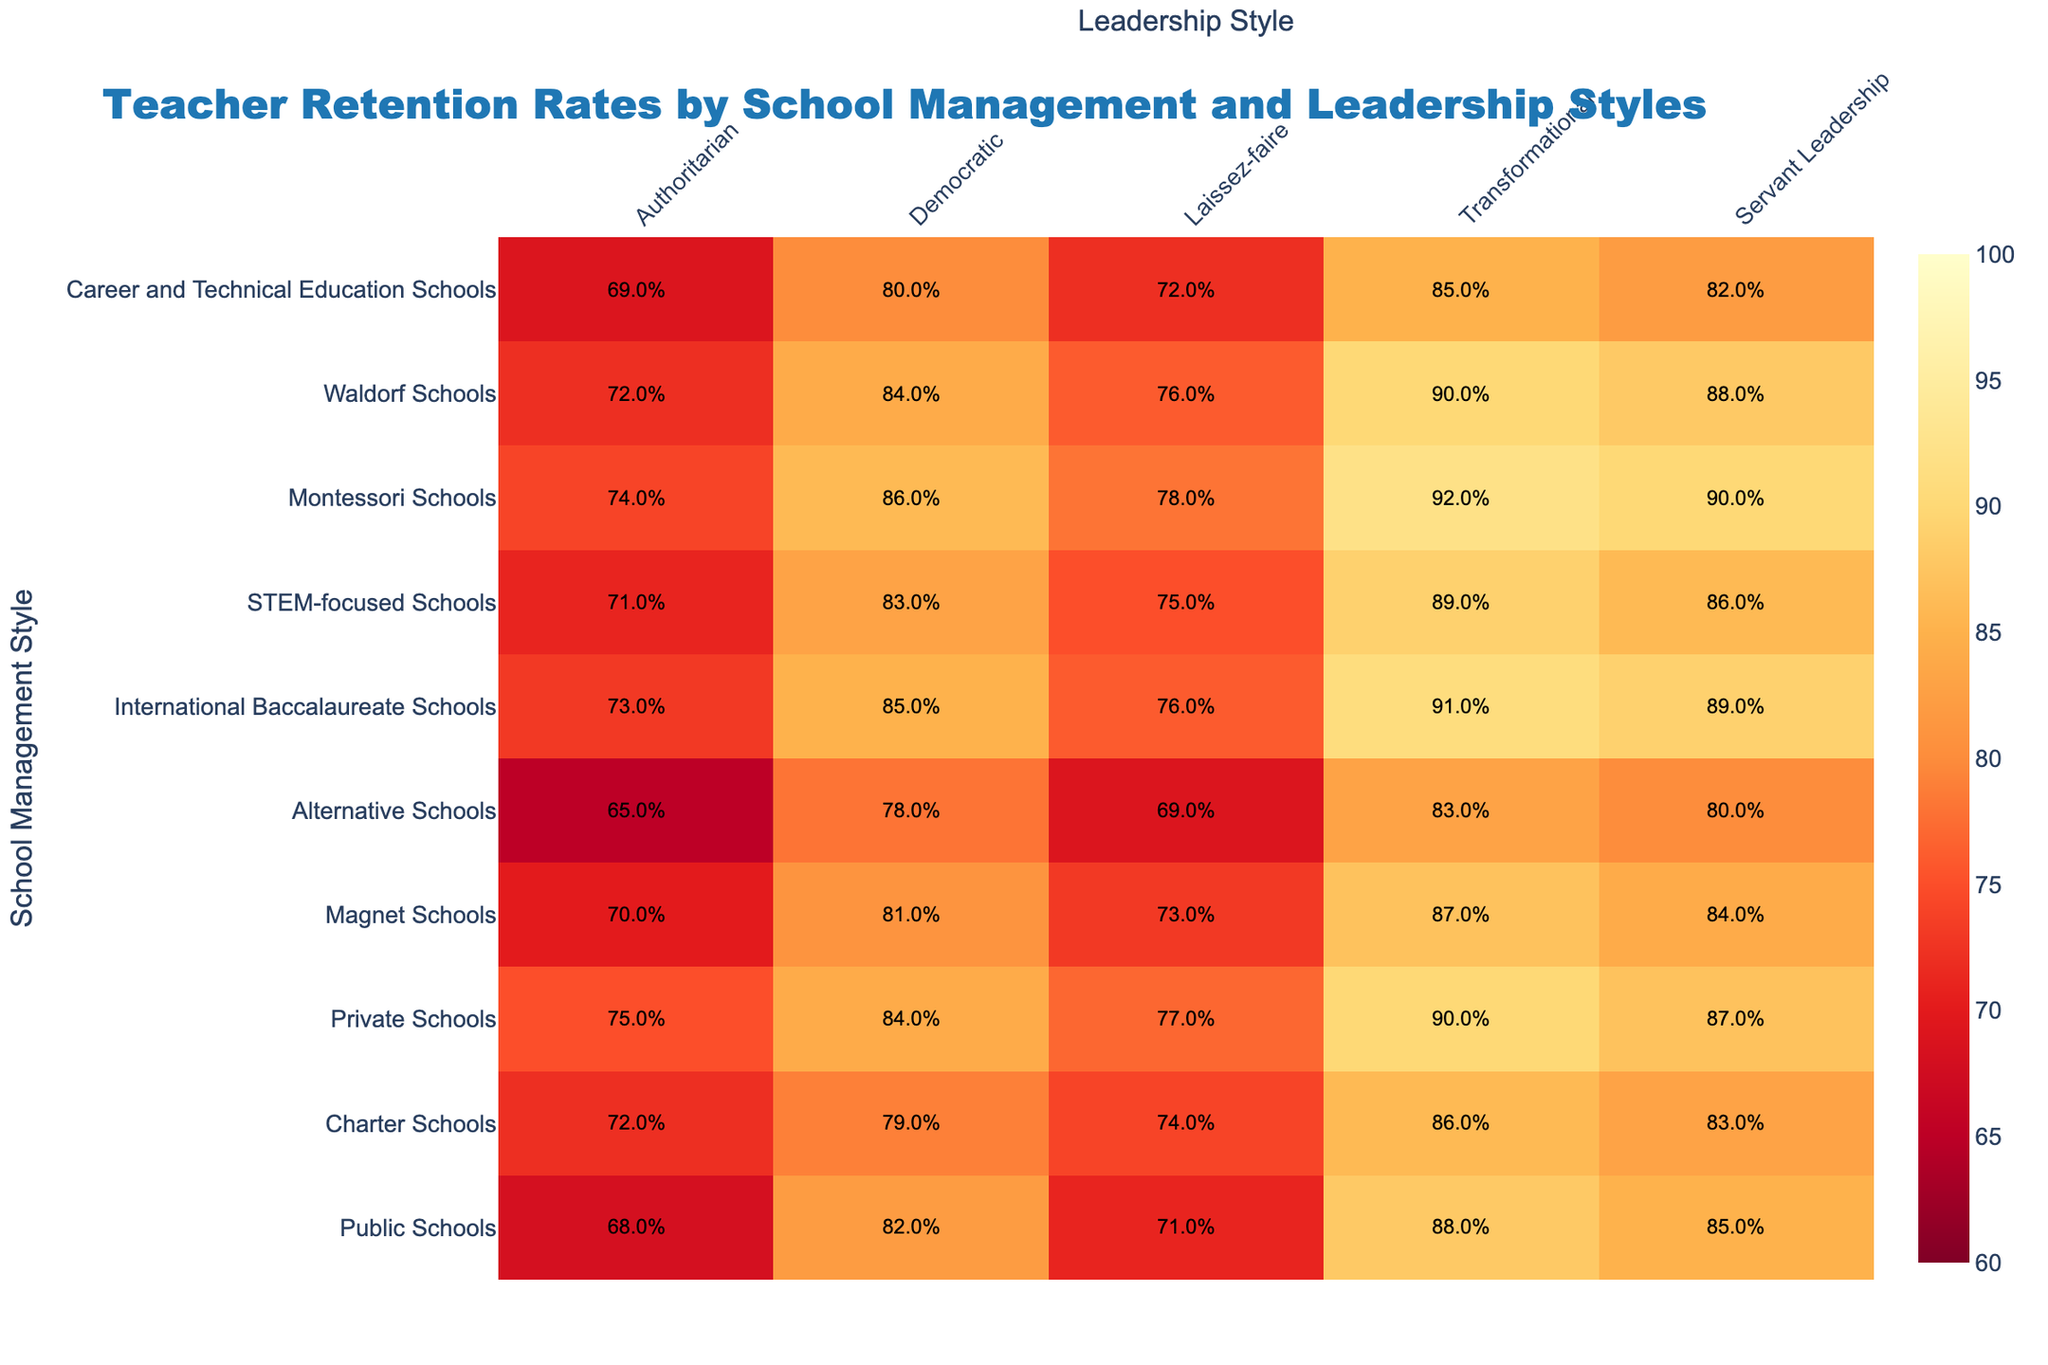What is the teacher retention rate for public schools using a democratic management style? According to the table, the retention rate for public schools under the democratic management style is 82%.
Answer: 82% Which school management style has the highest teacher retention rate under a transformational leadership style? The table shows that private schools have the highest retention rate of 90% under the transformational leadership style.
Answer: 90% Is the teacher retention rate in charter schools higher under authoritarian management style compared to alternative schools? The retention rate for charter schools using authoritarian management style is 72%, while for alternative schools it is 65%. Since 72% is higher than 65%, the answer is yes.
Answer: Yes What is the difference in teacher retention rates between Montessori and Waldorf schools under the servant leadership style? The retention rate for Montessori schools with servant leadership is 90% while Waldorf schools have an 88% retention rate. The difference is 90% - 88% = 2%.
Answer: 2% What is the average teacher retention rate across all management styles for STEM-focused schools? First, we add the retention rates: 71% + 83% + 75% + 89% + 86% = 404%. These rates are divided by 5 (the number of management styles), resulting in an average of 404% / 5 = 80.8%.
Answer: 80.8% Which school management style consistently shows the lowest teacher retention rates across all leadership styles? By examining the table, alternative schools show the lowest retention rates in multiple leadership styles, with the lowest being 65% under authoritarian management.
Answer: Alternative Schools Under which leadership style does the highest percentage of teacher retention occur across all school management styles? Looking at the table, the highest retention rate across all management styles is 92%, which occurs under transformational leadership for Montessori schools.
Answer: Transformational Leadership How does the retention rate for public schools under laissez-faire management style compare with the rate for private schools under the same management style? The retention rate for public schools under laissez-faire is 71% while private schools have 77%. Comparing these, 77% is higher than 71%, indicating a difference.
Answer: Private Schools Higher What is the trend in retention rates from authoritarian to servant leadership style for magnet schools? For magnet schools, the retention rates go as follows: authoritarian (70%), democratic (81%), laissez-faire (73%), transformational (87%), and servant leadership (84%). There is a peak in transformational, followed by a drop in servant leadership, indicating a fluctuating trend.
Answer: Fluctuating Trend Which type of school management style tends to have the most consistent teacher retention rates across different leadership styles? Upon review, public schools maintain relatively consistent rates ranging from 68% to 88% across the leadership styles. Other types show more variation.
Answer: Public Schools 